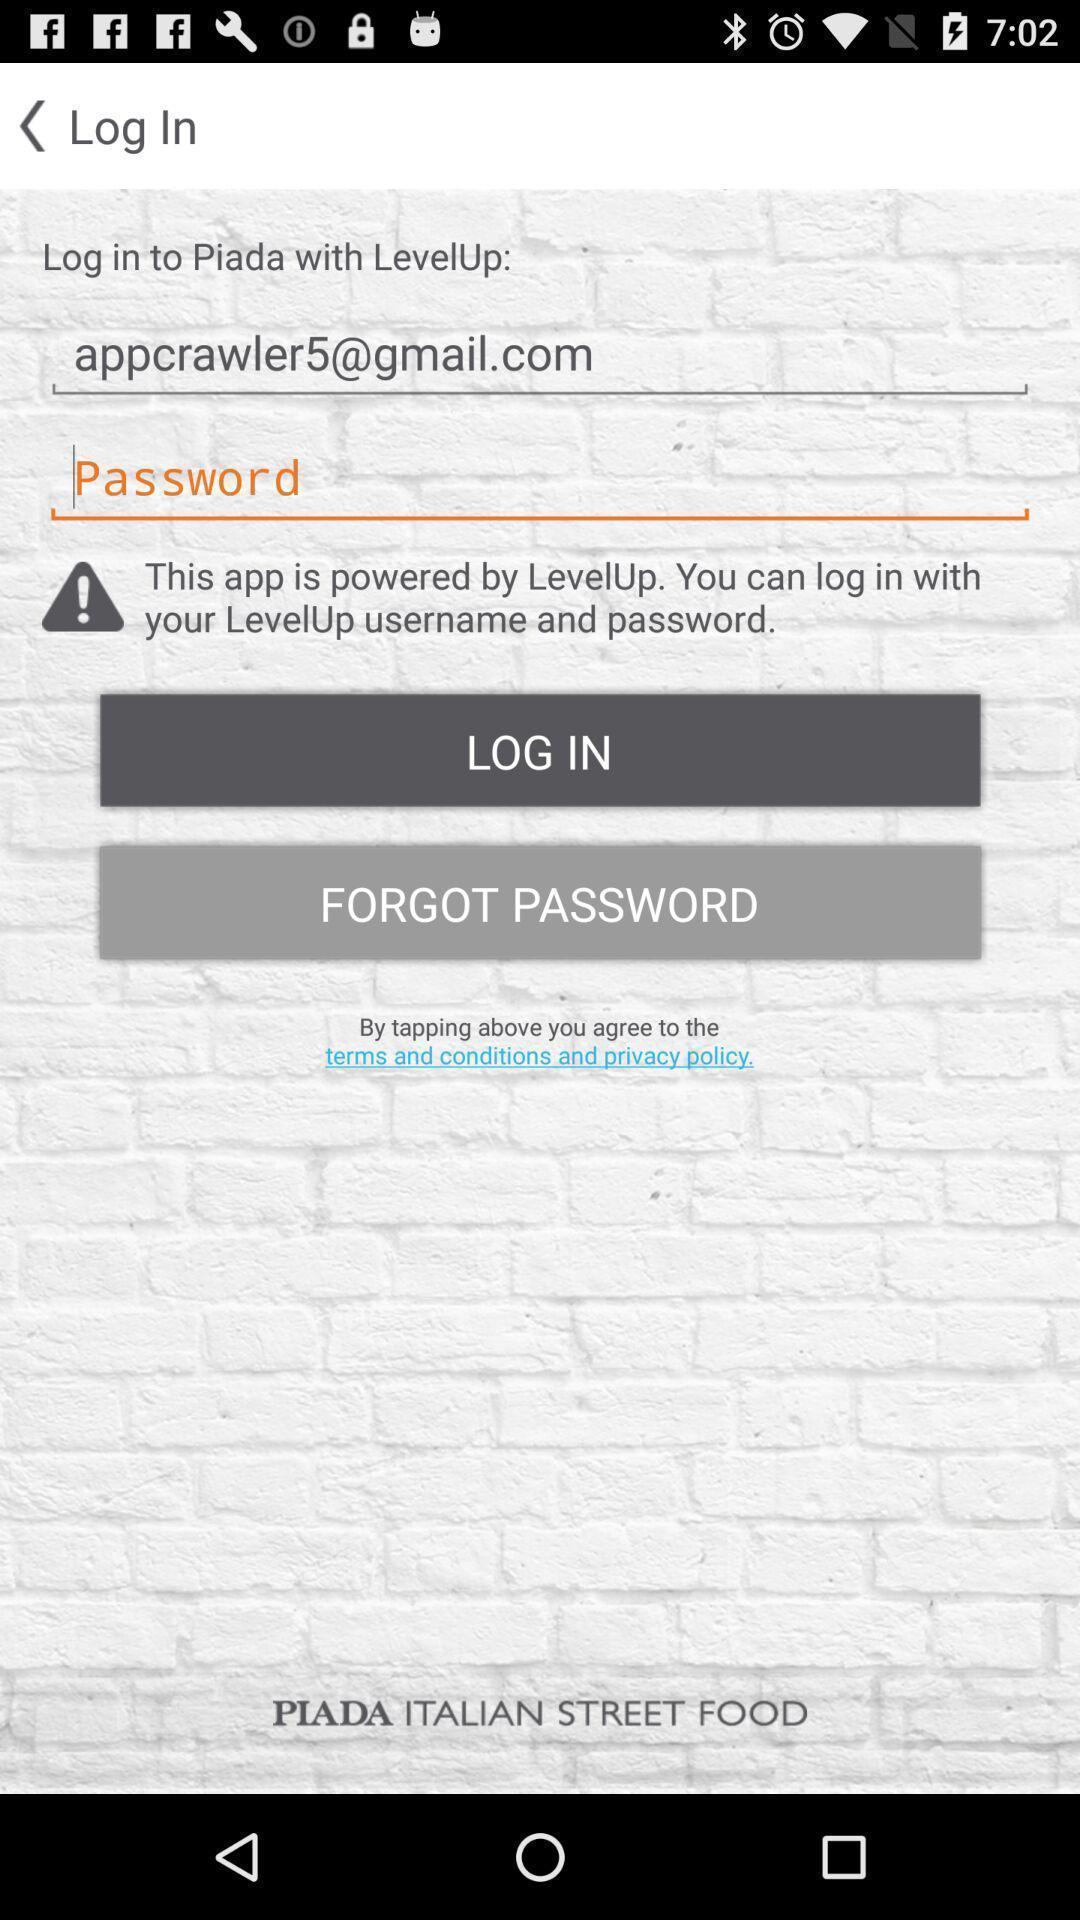Provide a description of this screenshot. Screen showing login information for an account. 